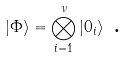Convert formula to latex. <formula><loc_0><loc_0><loc_500><loc_500>| \Phi \rangle = \bigotimes _ { i = 1 } ^ { \nu } | 0 _ { i } \rangle \text { .}</formula> 